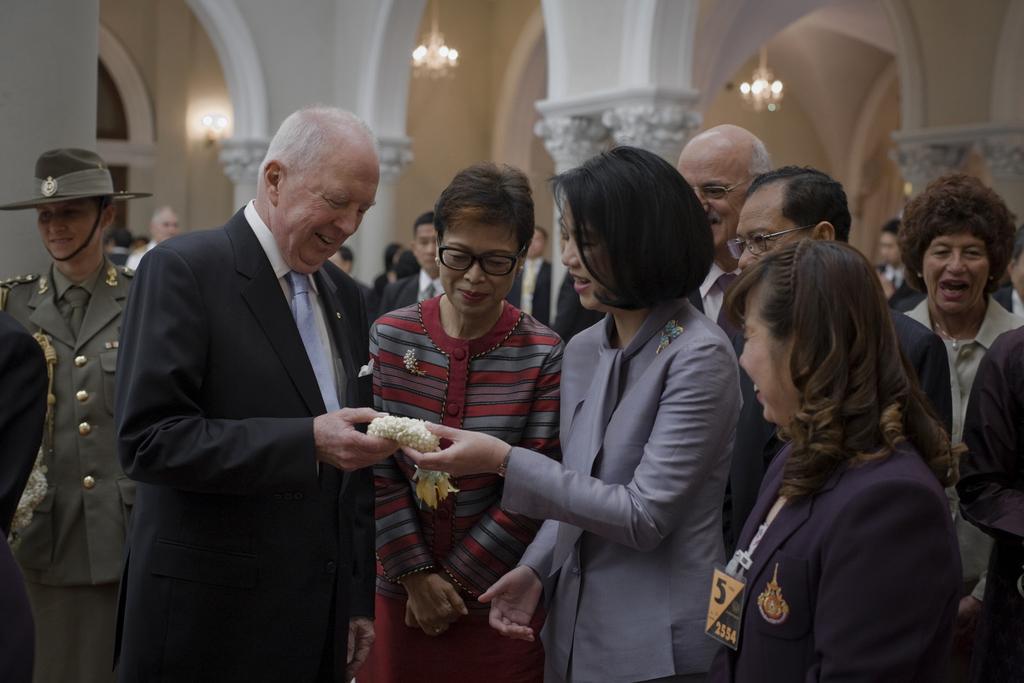Describe this image in one or two sentences. In the picture I can see these people are standing here and smiling. The background of the image is slightly blurred, where we can see a few more people standing, I can see pillars and chandeliers. 